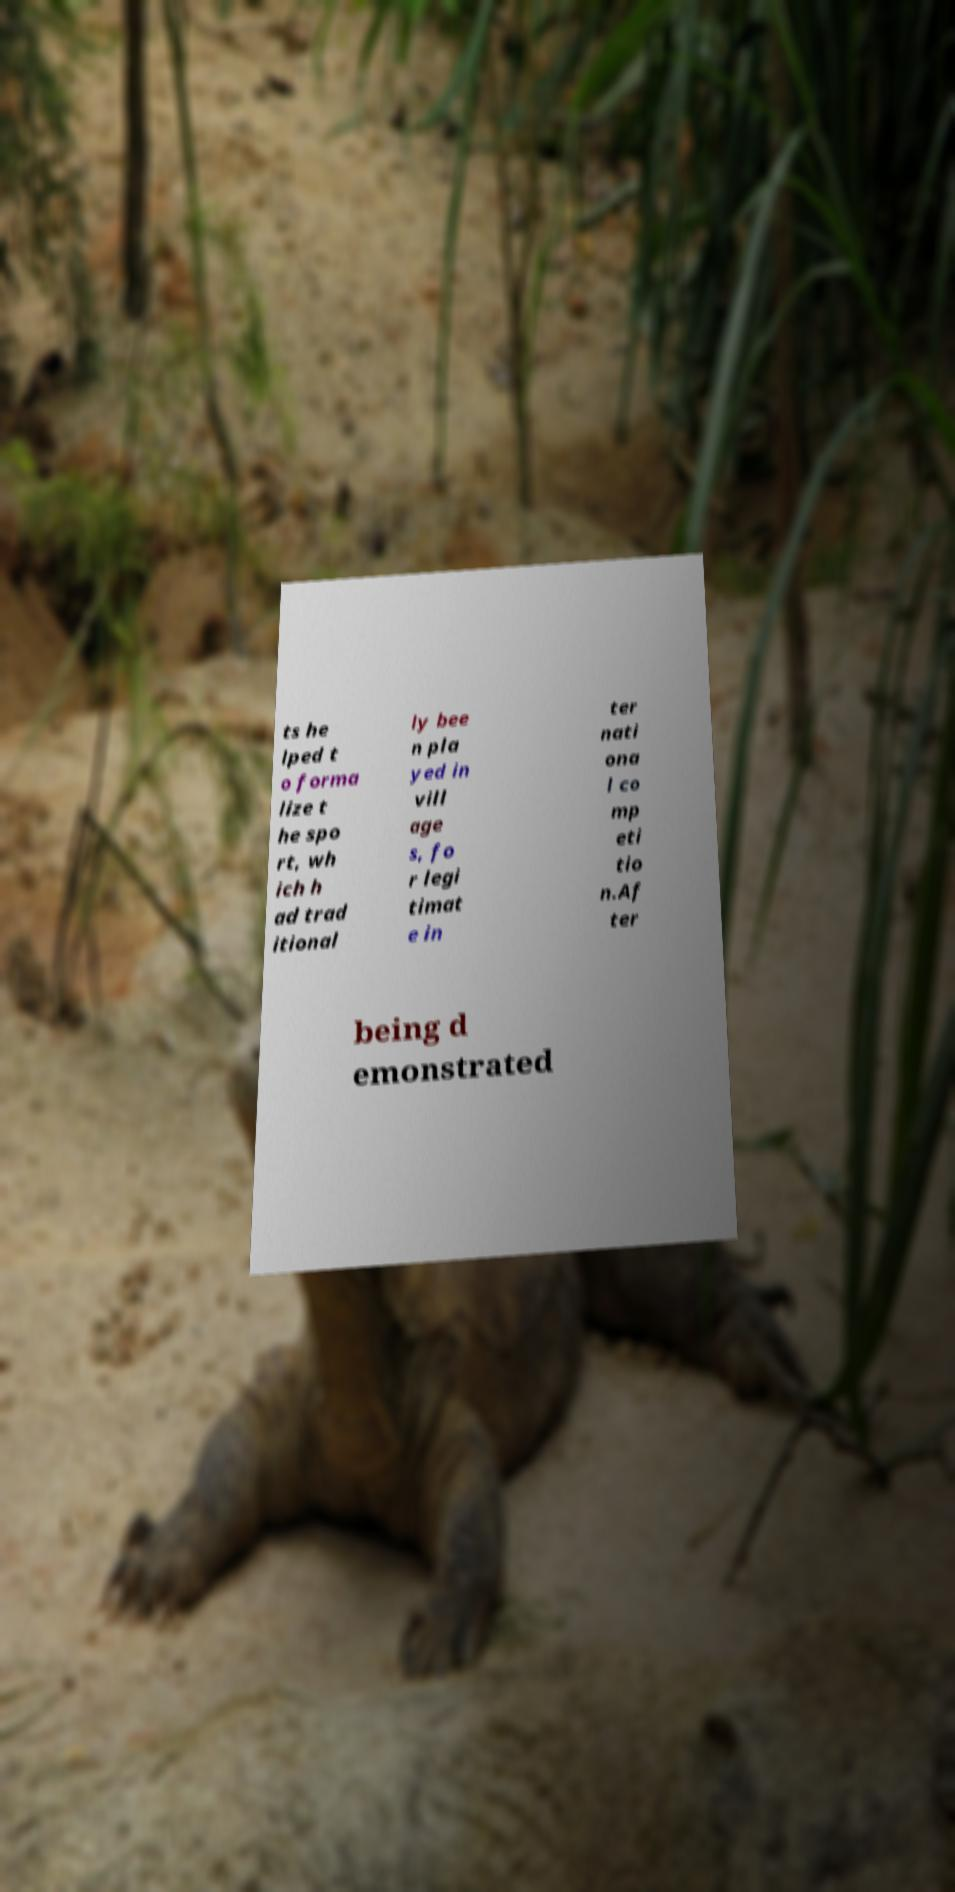There's text embedded in this image that I need extracted. Can you transcribe it verbatim? ts he lped t o forma lize t he spo rt, wh ich h ad trad itional ly bee n pla yed in vill age s, fo r legi timat e in ter nati ona l co mp eti tio n.Af ter being d emonstrated 